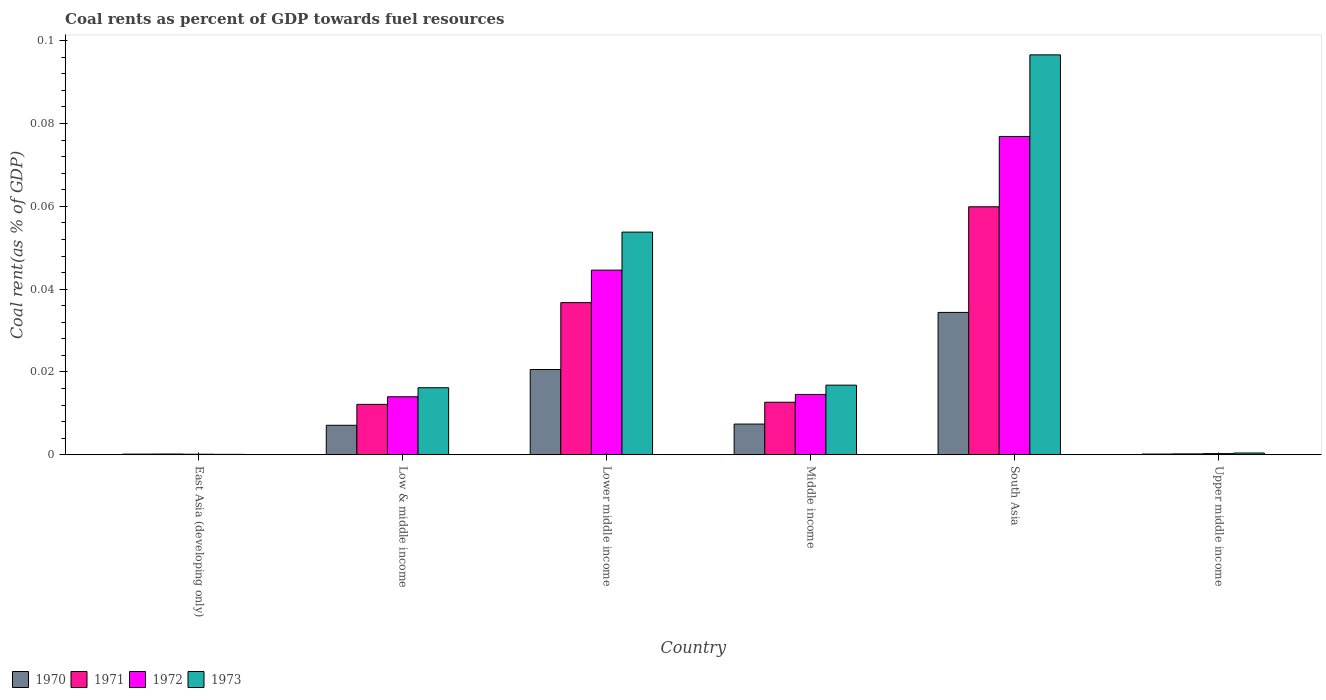How many different coloured bars are there?
Your answer should be compact. 4. How many groups of bars are there?
Ensure brevity in your answer.  6. Are the number of bars on each tick of the X-axis equal?
Make the answer very short. Yes. How many bars are there on the 3rd tick from the right?
Make the answer very short. 4. What is the label of the 3rd group of bars from the left?
Give a very brief answer. Lower middle income. In how many cases, is the number of bars for a given country not equal to the number of legend labels?
Offer a terse response. 0. What is the coal rent in 1972 in Middle income?
Your response must be concise. 0.01. Across all countries, what is the maximum coal rent in 1972?
Your answer should be compact. 0.08. Across all countries, what is the minimum coal rent in 1972?
Keep it short and to the point. 0. In which country was the coal rent in 1970 maximum?
Offer a very short reply. South Asia. In which country was the coal rent in 1972 minimum?
Make the answer very short. East Asia (developing only). What is the total coal rent in 1971 in the graph?
Offer a very short reply. 0.12. What is the difference between the coal rent in 1970 in East Asia (developing only) and that in Low & middle income?
Make the answer very short. -0.01. What is the difference between the coal rent in 1972 in Low & middle income and the coal rent in 1971 in South Asia?
Offer a terse response. -0.05. What is the average coal rent in 1971 per country?
Keep it short and to the point. 0.02. What is the difference between the coal rent of/in 1972 and coal rent of/in 1970 in Low & middle income?
Your response must be concise. 0.01. What is the ratio of the coal rent in 1973 in East Asia (developing only) to that in Low & middle income?
Keep it short and to the point. 0.01. What is the difference between the highest and the second highest coal rent in 1972?
Provide a short and direct response. 0.03. What is the difference between the highest and the lowest coal rent in 1971?
Your answer should be compact. 0.06. Is the sum of the coal rent in 1973 in South Asia and Upper middle income greater than the maximum coal rent in 1970 across all countries?
Ensure brevity in your answer.  Yes. What does the 3rd bar from the right in Middle income represents?
Ensure brevity in your answer.  1971. How many countries are there in the graph?
Your answer should be very brief. 6. What is the difference between two consecutive major ticks on the Y-axis?
Your response must be concise. 0.02. Does the graph contain any zero values?
Provide a succinct answer. No. How many legend labels are there?
Provide a succinct answer. 4. How are the legend labels stacked?
Provide a succinct answer. Horizontal. What is the title of the graph?
Ensure brevity in your answer.  Coal rents as percent of GDP towards fuel resources. Does "1996" appear as one of the legend labels in the graph?
Keep it short and to the point. No. What is the label or title of the Y-axis?
Your answer should be very brief. Coal rent(as % of GDP). What is the Coal rent(as % of GDP) of 1970 in East Asia (developing only)?
Give a very brief answer. 0. What is the Coal rent(as % of GDP) of 1971 in East Asia (developing only)?
Provide a succinct answer. 0. What is the Coal rent(as % of GDP) of 1972 in East Asia (developing only)?
Give a very brief answer. 0. What is the Coal rent(as % of GDP) of 1973 in East Asia (developing only)?
Offer a very short reply. 0. What is the Coal rent(as % of GDP) in 1970 in Low & middle income?
Your answer should be compact. 0.01. What is the Coal rent(as % of GDP) of 1971 in Low & middle income?
Provide a succinct answer. 0.01. What is the Coal rent(as % of GDP) of 1972 in Low & middle income?
Your answer should be compact. 0.01. What is the Coal rent(as % of GDP) in 1973 in Low & middle income?
Offer a terse response. 0.02. What is the Coal rent(as % of GDP) of 1970 in Lower middle income?
Offer a terse response. 0.02. What is the Coal rent(as % of GDP) in 1971 in Lower middle income?
Keep it short and to the point. 0.04. What is the Coal rent(as % of GDP) in 1972 in Lower middle income?
Your answer should be very brief. 0.04. What is the Coal rent(as % of GDP) in 1973 in Lower middle income?
Make the answer very short. 0.05. What is the Coal rent(as % of GDP) of 1970 in Middle income?
Your response must be concise. 0.01. What is the Coal rent(as % of GDP) in 1971 in Middle income?
Offer a very short reply. 0.01. What is the Coal rent(as % of GDP) of 1972 in Middle income?
Offer a terse response. 0.01. What is the Coal rent(as % of GDP) in 1973 in Middle income?
Offer a terse response. 0.02. What is the Coal rent(as % of GDP) in 1970 in South Asia?
Ensure brevity in your answer.  0.03. What is the Coal rent(as % of GDP) of 1971 in South Asia?
Keep it short and to the point. 0.06. What is the Coal rent(as % of GDP) of 1972 in South Asia?
Offer a terse response. 0.08. What is the Coal rent(as % of GDP) in 1973 in South Asia?
Offer a terse response. 0.1. What is the Coal rent(as % of GDP) of 1970 in Upper middle income?
Provide a short and direct response. 0. What is the Coal rent(as % of GDP) in 1971 in Upper middle income?
Your answer should be compact. 0. What is the Coal rent(as % of GDP) of 1972 in Upper middle income?
Provide a succinct answer. 0. What is the Coal rent(as % of GDP) in 1973 in Upper middle income?
Your answer should be very brief. 0. Across all countries, what is the maximum Coal rent(as % of GDP) of 1970?
Your response must be concise. 0.03. Across all countries, what is the maximum Coal rent(as % of GDP) in 1971?
Make the answer very short. 0.06. Across all countries, what is the maximum Coal rent(as % of GDP) in 1972?
Your response must be concise. 0.08. Across all countries, what is the maximum Coal rent(as % of GDP) in 1973?
Give a very brief answer. 0.1. Across all countries, what is the minimum Coal rent(as % of GDP) of 1970?
Ensure brevity in your answer.  0. Across all countries, what is the minimum Coal rent(as % of GDP) in 1971?
Provide a succinct answer. 0. Across all countries, what is the minimum Coal rent(as % of GDP) in 1972?
Keep it short and to the point. 0. Across all countries, what is the minimum Coal rent(as % of GDP) in 1973?
Ensure brevity in your answer.  0. What is the total Coal rent(as % of GDP) in 1970 in the graph?
Offer a terse response. 0.07. What is the total Coal rent(as % of GDP) of 1971 in the graph?
Your answer should be compact. 0.12. What is the total Coal rent(as % of GDP) in 1972 in the graph?
Offer a terse response. 0.15. What is the total Coal rent(as % of GDP) in 1973 in the graph?
Your answer should be compact. 0.18. What is the difference between the Coal rent(as % of GDP) in 1970 in East Asia (developing only) and that in Low & middle income?
Your answer should be compact. -0.01. What is the difference between the Coal rent(as % of GDP) of 1971 in East Asia (developing only) and that in Low & middle income?
Your answer should be very brief. -0.01. What is the difference between the Coal rent(as % of GDP) in 1972 in East Asia (developing only) and that in Low & middle income?
Provide a short and direct response. -0.01. What is the difference between the Coal rent(as % of GDP) in 1973 in East Asia (developing only) and that in Low & middle income?
Your answer should be very brief. -0.02. What is the difference between the Coal rent(as % of GDP) in 1970 in East Asia (developing only) and that in Lower middle income?
Give a very brief answer. -0.02. What is the difference between the Coal rent(as % of GDP) of 1971 in East Asia (developing only) and that in Lower middle income?
Offer a very short reply. -0.04. What is the difference between the Coal rent(as % of GDP) of 1972 in East Asia (developing only) and that in Lower middle income?
Keep it short and to the point. -0.04. What is the difference between the Coal rent(as % of GDP) in 1973 in East Asia (developing only) and that in Lower middle income?
Provide a succinct answer. -0.05. What is the difference between the Coal rent(as % of GDP) in 1970 in East Asia (developing only) and that in Middle income?
Your response must be concise. -0.01. What is the difference between the Coal rent(as % of GDP) in 1971 in East Asia (developing only) and that in Middle income?
Your response must be concise. -0.01. What is the difference between the Coal rent(as % of GDP) in 1972 in East Asia (developing only) and that in Middle income?
Your answer should be very brief. -0.01. What is the difference between the Coal rent(as % of GDP) of 1973 in East Asia (developing only) and that in Middle income?
Keep it short and to the point. -0.02. What is the difference between the Coal rent(as % of GDP) of 1970 in East Asia (developing only) and that in South Asia?
Give a very brief answer. -0.03. What is the difference between the Coal rent(as % of GDP) of 1971 in East Asia (developing only) and that in South Asia?
Offer a very short reply. -0.06. What is the difference between the Coal rent(as % of GDP) of 1972 in East Asia (developing only) and that in South Asia?
Your answer should be compact. -0.08. What is the difference between the Coal rent(as % of GDP) of 1973 in East Asia (developing only) and that in South Asia?
Provide a short and direct response. -0.1. What is the difference between the Coal rent(as % of GDP) of 1970 in East Asia (developing only) and that in Upper middle income?
Your response must be concise. -0. What is the difference between the Coal rent(as % of GDP) in 1972 in East Asia (developing only) and that in Upper middle income?
Provide a succinct answer. -0. What is the difference between the Coal rent(as % of GDP) in 1973 in East Asia (developing only) and that in Upper middle income?
Provide a succinct answer. -0. What is the difference between the Coal rent(as % of GDP) in 1970 in Low & middle income and that in Lower middle income?
Offer a very short reply. -0.01. What is the difference between the Coal rent(as % of GDP) in 1971 in Low & middle income and that in Lower middle income?
Make the answer very short. -0.02. What is the difference between the Coal rent(as % of GDP) of 1972 in Low & middle income and that in Lower middle income?
Offer a terse response. -0.03. What is the difference between the Coal rent(as % of GDP) of 1973 in Low & middle income and that in Lower middle income?
Give a very brief answer. -0.04. What is the difference between the Coal rent(as % of GDP) of 1970 in Low & middle income and that in Middle income?
Offer a terse response. -0. What is the difference between the Coal rent(as % of GDP) of 1971 in Low & middle income and that in Middle income?
Your response must be concise. -0. What is the difference between the Coal rent(as % of GDP) in 1972 in Low & middle income and that in Middle income?
Ensure brevity in your answer.  -0. What is the difference between the Coal rent(as % of GDP) in 1973 in Low & middle income and that in Middle income?
Give a very brief answer. -0. What is the difference between the Coal rent(as % of GDP) of 1970 in Low & middle income and that in South Asia?
Your response must be concise. -0.03. What is the difference between the Coal rent(as % of GDP) in 1971 in Low & middle income and that in South Asia?
Keep it short and to the point. -0.05. What is the difference between the Coal rent(as % of GDP) of 1972 in Low & middle income and that in South Asia?
Keep it short and to the point. -0.06. What is the difference between the Coal rent(as % of GDP) in 1973 in Low & middle income and that in South Asia?
Your answer should be compact. -0.08. What is the difference between the Coal rent(as % of GDP) of 1970 in Low & middle income and that in Upper middle income?
Provide a short and direct response. 0.01. What is the difference between the Coal rent(as % of GDP) of 1971 in Low & middle income and that in Upper middle income?
Offer a terse response. 0.01. What is the difference between the Coal rent(as % of GDP) of 1972 in Low & middle income and that in Upper middle income?
Your answer should be very brief. 0.01. What is the difference between the Coal rent(as % of GDP) of 1973 in Low & middle income and that in Upper middle income?
Make the answer very short. 0.02. What is the difference between the Coal rent(as % of GDP) in 1970 in Lower middle income and that in Middle income?
Your response must be concise. 0.01. What is the difference between the Coal rent(as % of GDP) of 1971 in Lower middle income and that in Middle income?
Your answer should be very brief. 0.02. What is the difference between the Coal rent(as % of GDP) of 1972 in Lower middle income and that in Middle income?
Your answer should be very brief. 0.03. What is the difference between the Coal rent(as % of GDP) of 1973 in Lower middle income and that in Middle income?
Your answer should be compact. 0.04. What is the difference between the Coal rent(as % of GDP) in 1970 in Lower middle income and that in South Asia?
Keep it short and to the point. -0.01. What is the difference between the Coal rent(as % of GDP) in 1971 in Lower middle income and that in South Asia?
Ensure brevity in your answer.  -0.02. What is the difference between the Coal rent(as % of GDP) of 1972 in Lower middle income and that in South Asia?
Offer a very short reply. -0.03. What is the difference between the Coal rent(as % of GDP) of 1973 in Lower middle income and that in South Asia?
Your response must be concise. -0.04. What is the difference between the Coal rent(as % of GDP) in 1970 in Lower middle income and that in Upper middle income?
Provide a succinct answer. 0.02. What is the difference between the Coal rent(as % of GDP) of 1971 in Lower middle income and that in Upper middle income?
Give a very brief answer. 0.04. What is the difference between the Coal rent(as % of GDP) of 1972 in Lower middle income and that in Upper middle income?
Offer a very short reply. 0.04. What is the difference between the Coal rent(as % of GDP) in 1973 in Lower middle income and that in Upper middle income?
Make the answer very short. 0.05. What is the difference between the Coal rent(as % of GDP) of 1970 in Middle income and that in South Asia?
Make the answer very short. -0.03. What is the difference between the Coal rent(as % of GDP) in 1971 in Middle income and that in South Asia?
Keep it short and to the point. -0.05. What is the difference between the Coal rent(as % of GDP) of 1972 in Middle income and that in South Asia?
Your answer should be compact. -0.06. What is the difference between the Coal rent(as % of GDP) of 1973 in Middle income and that in South Asia?
Keep it short and to the point. -0.08. What is the difference between the Coal rent(as % of GDP) in 1970 in Middle income and that in Upper middle income?
Your answer should be compact. 0.01. What is the difference between the Coal rent(as % of GDP) of 1971 in Middle income and that in Upper middle income?
Provide a short and direct response. 0.01. What is the difference between the Coal rent(as % of GDP) of 1972 in Middle income and that in Upper middle income?
Make the answer very short. 0.01. What is the difference between the Coal rent(as % of GDP) in 1973 in Middle income and that in Upper middle income?
Offer a very short reply. 0.02. What is the difference between the Coal rent(as % of GDP) in 1970 in South Asia and that in Upper middle income?
Make the answer very short. 0.03. What is the difference between the Coal rent(as % of GDP) in 1971 in South Asia and that in Upper middle income?
Give a very brief answer. 0.06. What is the difference between the Coal rent(as % of GDP) of 1972 in South Asia and that in Upper middle income?
Give a very brief answer. 0.08. What is the difference between the Coal rent(as % of GDP) in 1973 in South Asia and that in Upper middle income?
Ensure brevity in your answer.  0.1. What is the difference between the Coal rent(as % of GDP) in 1970 in East Asia (developing only) and the Coal rent(as % of GDP) in 1971 in Low & middle income?
Your answer should be very brief. -0.01. What is the difference between the Coal rent(as % of GDP) of 1970 in East Asia (developing only) and the Coal rent(as % of GDP) of 1972 in Low & middle income?
Your answer should be very brief. -0.01. What is the difference between the Coal rent(as % of GDP) in 1970 in East Asia (developing only) and the Coal rent(as % of GDP) in 1973 in Low & middle income?
Your response must be concise. -0.02. What is the difference between the Coal rent(as % of GDP) in 1971 in East Asia (developing only) and the Coal rent(as % of GDP) in 1972 in Low & middle income?
Provide a short and direct response. -0.01. What is the difference between the Coal rent(as % of GDP) of 1971 in East Asia (developing only) and the Coal rent(as % of GDP) of 1973 in Low & middle income?
Offer a terse response. -0.02. What is the difference between the Coal rent(as % of GDP) in 1972 in East Asia (developing only) and the Coal rent(as % of GDP) in 1973 in Low & middle income?
Your answer should be very brief. -0.02. What is the difference between the Coal rent(as % of GDP) in 1970 in East Asia (developing only) and the Coal rent(as % of GDP) in 1971 in Lower middle income?
Your response must be concise. -0.04. What is the difference between the Coal rent(as % of GDP) of 1970 in East Asia (developing only) and the Coal rent(as % of GDP) of 1972 in Lower middle income?
Give a very brief answer. -0.04. What is the difference between the Coal rent(as % of GDP) in 1970 in East Asia (developing only) and the Coal rent(as % of GDP) in 1973 in Lower middle income?
Provide a short and direct response. -0.05. What is the difference between the Coal rent(as % of GDP) of 1971 in East Asia (developing only) and the Coal rent(as % of GDP) of 1972 in Lower middle income?
Keep it short and to the point. -0.04. What is the difference between the Coal rent(as % of GDP) in 1971 in East Asia (developing only) and the Coal rent(as % of GDP) in 1973 in Lower middle income?
Keep it short and to the point. -0.05. What is the difference between the Coal rent(as % of GDP) in 1972 in East Asia (developing only) and the Coal rent(as % of GDP) in 1973 in Lower middle income?
Provide a succinct answer. -0.05. What is the difference between the Coal rent(as % of GDP) in 1970 in East Asia (developing only) and the Coal rent(as % of GDP) in 1971 in Middle income?
Provide a succinct answer. -0.01. What is the difference between the Coal rent(as % of GDP) in 1970 in East Asia (developing only) and the Coal rent(as % of GDP) in 1972 in Middle income?
Make the answer very short. -0.01. What is the difference between the Coal rent(as % of GDP) in 1970 in East Asia (developing only) and the Coal rent(as % of GDP) in 1973 in Middle income?
Your answer should be very brief. -0.02. What is the difference between the Coal rent(as % of GDP) of 1971 in East Asia (developing only) and the Coal rent(as % of GDP) of 1972 in Middle income?
Keep it short and to the point. -0.01. What is the difference between the Coal rent(as % of GDP) in 1971 in East Asia (developing only) and the Coal rent(as % of GDP) in 1973 in Middle income?
Your response must be concise. -0.02. What is the difference between the Coal rent(as % of GDP) in 1972 in East Asia (developing only) and the Coal rent(as % of GDP) in 1973 in Middle income?
Offer a terse response. -0.02. What is the difference between the Coal rent(as % of GDP) of 1970 in East Asia (developing only) and the Coal rent(as % of GDP) of 1971 in South Asia?
Make the answer very short. -0.06. What is the difference between the Coal rent(as % of GDP) of 1970 in East Asia (developing only) and the Coal rent(as % of GDP) of 1972 in South Asia?
Offer a very short reply. -0.08. What is the difference between the Coal rent(as % of GDP) of 1970 in East Asia (developing only) and the Coal rent(as % of GDP) of 1973 in South Asia?
Give a very brief answer. -0.1. What is the difference between the Coal rent(as % of GDP) of 1971 in East Asia (developing only) and the Coal rent(as % of GDP) of 1972 in South Asia?
Offer a terse response. -0.08. What is the difference between the Coal rent(as % of GDP) in 1971 in East Asia (developing only) and the Coal rent(as % of GDP) in 1973 in South Asia?
Your answer should be very brief. -0.1. What is the difference between the Coal rent(as % of GDP) in 1972 in East Asia (developing only) and the Coal rent(as % of GDP) in 1973 in South Asia?
Your response must be concise. -0.1. What is the difference between the Coal rent(as % of GDP) of 1970 in East Asia (developing only) and the Coal rent(as % of GDP) of 1971 in Upper middle income?
Provide a short and direct response. -0. What is the difference between the Coal rent(as % of GDP) in 1970 in East Asia (developing only) and the Coal rent(as % of GDP) in 1972 in Upper middle income?
Give a very brief answer. -0. What is the difference between the Coal rent(as % of GDP) in 1970 in East Asia (developing only) and the Coal rent(as % of GDP) in 1973 in Upper middle income?
Your answer should be very brief. -0. What is the difference between the Coal rent(as % of GDP) of 1971 in East Asia (developing only) and the Coal rent(as % of GDP) of 1972 in Upper middle income?
Provide a succinct answer. -0. What is the difference between the Coal rent(as % of GDP) of 1971 in East Asia (developing only) and the Coal rent(as % of GDP) of 1973 in Upper middle income?
Your response must be concise. -0. What is the difference between the Coal rent(as % of GDP) of 1972 in East Asia (developing only) and the Coal rent(as % of GDP) of 1973 in Upper middle income?
Make the answer very short. -0. What is the difference between the Coal rent(as % of GDP) of 1970 in Low & middle income and the Coal rent(as % of GDP) of 1971 in Lower middle income?
Provide a succinct answer. -0.03. What is the difference between the Coal rent(as % of GDP) in 1970 in Low & middle income and the Coal rent(as % of GDP) in 1972 in Lower middle income?
Provide a short and direct response. -0.04. What is the difference between the Coal rent(as % of GDP) in 1970 in Low & middle income and the Coal rent(as % of GDP) in 1973 in Lower middle income?
Make the answer very short. -0.05. What is the difference between the Coal rent(as % of GDP) of 1971 in Low & middle income and the Coal rent(as % of GDP) of 1972 in Lower middle income?
Your answer should be compact. -0.03. What is the difference between the Coal rent(as % of GDP) of 1971 in Low & middle income and the Coal rent(as % of GDP) of 1973 in Lower middle income?
Offer a terse response. -0.04. What is the difference between the Coal rent(as % of GDP) of 1972 in Low & middle income and the Coal rent(as % of GDP) of 1973 in Lower middle income?
Offer a terse response. -0.04. What is the difference between the Coal rent(as % of GDP) in 1970 in Low & middle income and the Coal rent(as % of GDP) in 1971 in Middle income?
Make the answer very short. -0.01. What is the difference between the Coal rent(as % of GDP) of 1970 in Low & middle income and the Coal rent(as % of GDP) of 1972 in Middle income?
Your answer should be compact. -0.01. What is the difference between the Coal rent(as % of GDP) of 1970 in Low & middle income and the Coal rent(as % of GDP) of 1973 in Middle income?
Give a very brief answer. -0.01. What is the difference between the Coal rent(as % of GDP) in 1971 in Low & middle income and the Coal rent(as % of GDP) in 1972 in Middle income?
Make the answer very short. -0. What is the difference between the Coal rent(as % of GDP) of 1971 in Low & middle income and the Coal rent(as % of GDP) of 1973 in Middle income?
Provide a succinct answer. -0. What is the difference between the Coal rent(as % of GDP) of 1972 in Low & middle income and the Coal rent(as % of GDP) of 1973 in Middle income?
Provide a succinct answer. -0. What is the difference between the Coal rent(as % of GDP) in 1970 in Low & middle income and the Coal rent(as % of GDP) in 1971 in South Asia?
Your response must be concise. -0.05. What is the difference between the Coal rent(as % of GDP) in 1970 in Low & middle income and the Coal rent(as % of GDP) in 1972 in South Asia?
Your answer should be very brief. -0.07. What is the difference between the Coal rent(as % of GDP) of 1970 in Low & middle income and the Coal rent(as % of GDP) of 1973 in South Asia?
Offer a very short reply. -0.09. What is the difference between the Coal rent(as % of GDP) in 1971 in Low & middle income and the Coal rent(as % of GDP) in 1972 in South Asia?
Offer a terse response. -0.06. What is the difference between the Coal rent(as % of GDP) in 1971 in Low & middle income and the Coal rent(as % of GDP) in 1973 in South Asia?
Offer a terse response. -0.08. What is the difference between the Coal rent(as % of GDP) of 1972 in Low & middle income and the Coal rent(as % of GDP) of 1973 in South Asia?
Give a very brief answer. -0.08. What is the difference between the Coal rent(as % of GDP) in 1970 in Low & middle income and the Coal rent(as % of GDP) in 1971 in Upper middle income?
Make the answer very short. 0.01. What is the difference between the Coal rent(as % of GDP) in 1970 in Low & middle income and the Coal rent(as % of GDP) in 1972 in Upper middle income?
Your response must be concise. 0.01. What is the difference between the Coal rent(as % of GDP) of 1970 in Low & middle income and the Coal rent(as % of GDP) of 1973 in Upper middle income?
Your answer should be compact. 0.01. What is the difference between the Coal rent(as % of GDP) of 1971 in Low & middle income and the Coal rent(as % of GDP) of 1972 in Upper middle income?
Offer a terse response. 0.01. What is the difference between the Coal rent(as % of GDP) in 1971 in Low & middle income and the Coal rent(as % of GDP) in 1973 in Upper middle income?
Your answer should be compact. 0.01. What is the difference between the Coal rent(as % of GDP) of 1972 in Low & middle income and the Coal rent(as % of GDP) of 1973 in Upper middle income?
Your answer should be compact. 0.01. What is the difference between the Coal rent(as % of GDP) of 1970 in Lower middle income and the Coal rent(as % of GDP) of 1971 in Middle income?
Ensure brevity in your answer.  0.01. What is the difference between the Coal rent(as % of GDP) of 1970 in Lower middle income and the Coal rent(as % of GDP) of 1972 in Middle income?
Keep it short and to the point. 0.01. What is the difference between the Coal rent(as % of GDP) of 1970 in Lower middle income and the Coal rent(as % of GDP) of 1973 in Middle income?
Keep it short and to the point. 0. What is the difference between the Coal rent(as % of GDP) in 1971 in Lower middle income and the Coal rent(as % of GDP) in 1972 in Middle income?
Ensure brevity in your answer.  0.02. What is the difference between the Coal rent(as % of GDP) of 1971 in Lower middle income and the Coal rent(as % of GDP) of 1973 in Middle income?
Ensure brevity in your answer.  0.02. What is the difference between the Coal rent(as % of GDP) of 1972 in Lower middle income and the Coal rent(as % of GDP) of 1973 in Middle income?
Your response must be concise. 0.03. What is the difference between the Coal rent(as % of GDP) of 1970 in Lower middle income and the Coal rent(as % of GDP) of 1971 in South Asia?
Provide a succinct answer. -0.04. What is the difference between the Coal rent(as % of GDP) of 1970 in Lower middle income and the Coal rent(as % of GDP) of 1972 in South Asia?
Make the answer very short. -0.06. What is the difference between the Coal rent(as % of GDP) of 1970 in Lower middle income and the Coal rent(as % of GDP) of 1973 in South Asia?
Offer a terse response. -0.08. What is the difference between the Coal rent(as % of GDP) of 1971 in Lower middle income and the Coal rent(as % of GDP) of 1972 in South Asia?
Ensure brevity in your answer.  -0.04. What is the difference between the Coal rent(as % of GDP) in 1971 in Lower middle income and the Coal rent(as % of GDP) in 1973 in South Asia?
Your response must be concise. -0.06. What is the difference between the Coal rent(as % of GDP) in 1972 in Lower middle income and the Coal rent(as % of GDP) in 1973 in South Asia?
Provide a succinct answer. -0.05. What is the difference between the Coal rent(as % of GDP) in 1970 in Lower middle income and the Coal rent(as % of GDP) in 1971 in Upper middle income?
Make the answer very short. 0.02. What is the difference between the Coal rent(as % of GDP) in 1970 in Lower middle income and the Coal rent(as % of GDP) in 1972 in Upper middle income?
Give a very brief answer. 0.02. What is the difference between the Coal rent(as % of GDP) in 1970 in Lower middle income and the Coal rent(as % of GDP) in 1973 in Upper middle income?
Ensure brevity in your answer.  0.02. What is the difference between the Coal rent(as % of GDP) in 1971 in Lower middle income and the Coal rent(as % of GDP) in 1972 in Upper middle income?
Provide a succinct answer. 0.04. What is the difference between the Coal rent(as % of GDP) of 1971 in Lower middle income and the Coal rent(as % of GDP) of 1973 in Upper middle income?
Your answer should be compact. 0.04. What is the difference between the Coal rent(as % of GDP) in 1972 in Lower middle income and the Coal rent(as % of GDP) in 1973 in Upper middle income?
Ensure brevity in your answer.  0.04. What is the difference between the Coal rent(as % of GDP) in 1970 in Middle income and the Coal rent(as % of GDP) in 1971 in South Asia?
Offer a very short reply. -0.05. What is the difference between the Coal rent(as % of GDP) in 1970 in Middle income and the Coal rent(as % of GDP) in 1972 in South Asia?
Provide a succinct answer. -0.07. What is the difference between the Coal rent(as % of GDP) of 1970 in Middle income and the Coal rent(as % of GDP) of 1973 in South Asia?
Your answer should be very brief. -0.09. What is the difference between the Coal rent(as % of GDP) in 1971 in Middle income and the Coal rent(as % of GDP) in 1972 in South Asia?
Keep it short and to the point. -0.06. What is the difference between the Coal rent(as % of GDP) of 1971 in Middle income and the Coal rent(as % of GDP) of 1973 in South Asia?
Your answer should be compact. -0.08. What is the difference between the Coal rent(as % of GDP) in 1972 in Middle income and the Coal rent(as % of GDP) in 1973 in South Asia?
Your response must be concise. -0.08. What is the difference between the Coal rent(as % of GDP) in 1970 in Middle income and the Coal rent(as % of GDP) in 1971 in Upper middle income?
Give a very brief answer. 0.01. What is the difference between the Coal rent(as % of GDP) of 1970 in Middle income and the Coal rent(as % of GDP) of 1972 in Upper middle income?
Give a very brief answer. 0.01. What is the difference between the Coal rent(as % of GDP) of 1970 in Middle income and the Coal rent(as % of GDP) of 1973 in Upper middle income?
Your answer should be compact. 0.01. What is the difference between the Coal rent(as % of GDP) in 1971 in Middle income and the Coal rent(as % of GDP) in 1972 in Upper middle income?
Give a very brief answer. 0.01. What is the difference between the Coal rent(as % of GDP) in 1971 in Middle income and the Coal rent(as % of GDP) in 1973 in Upper middle income?
Provide a short and direct response. 0.01. What is the difference between the Coal rent(as % of GDP) in 1972 in Middle income and the Coal rent(as % of GDP) in 1973 in Upper middle income?
Your answer should be very brief. 0.01. What is the difference between the Coal rent(as % of GDP) of 1970 in South Asia and the Coal rent(as % of GDP) of 1971 in Upper middle income?
Provide a succinct answer. 0.03. What is the difference between the Coal rent(as % of GDP) of 1970 in South Asia and the Coal rent(as % of GDP) of 1972 in Upper middle income?
Provide a succinct answer. 0.03. What is the difference between the Coal rent(as % of GDP) of 1970 in South Asia and the Coal rent(as % of GDP) of 1973 in Upper middle income?
Offer a very short reply. 0.03. What is the difference between the Coal rent(as % of GDP) of 1971 in South Asia and the Coal rent(as % of GDP) of 1972 in Upper middle income?
Keep it short and to the point. 0.06. What is the difference between the Coal rent(as % of GDP) of 1971 in South Asia and the Coal rent(as % of GDP) of 1973 in Upper middle income?
Your answer should be compact. 0.06. What is the difference between the Coal rent(as % of GDP) in 1972 in South Asia and the Coal rent(as % of GDP) in 1973 in Upper middle income?
Offer a terse response. 0.08. What is the average Coal rent(as % of GDP) of 1970 per country?
Ensure brevity in your answer.  0.01. What is the average Coal rent(as % of GDP) in 1971 per country?
Offer a very short reply. 0.02. What is the average Coal rent(as % of GDP) of 1972 per country?
Keep it short and to the point. 0.03. What is the average Coal rent(as % of GDP) in 1973 per country?
Give a very brief answer. 0.03. What is the difference between the Coal rent(as % of GDP) of 1970 and Coal rent(as % of GDP) of 1971 in East Asia (developing only)?
Ensure brevity in your answer.  -0. What is the difference between the Coal rent(as % of GDP) in 1970 and Coal rent(as % of GDP) in 1972 in East Asia (developing only)?
Your answer should be compact. 0. What is the difference between the Coal rent(as % of GDP) of 1971 and Coal rent(as % of GDP) of 1972 in East Asia (developing only)?
Keep it short and to the point. 0. What is the difference between the Coal rent(as % of GDP) of 1972 and Coal rent(as % of GDP) of 1973 in East Asia (developing only)?
Offer a terse response. 0. What is the difference between the Coal rent(as % of GDP) in 1970 and Coal rent(as % of GDP) in 1971 in Low & middle income?
Give a very brief answer. -0.01. What is the difference between the Coal rent(as % of GDP) of 1970 and Coal rent(as % of GDP) of 1972 in Low & middle income?
Your answer should be very brief. -0.01. What is the difference between the Coal rent(as % of GDP) in 1970 and Coal rent(as % of GDP) in 1973 in Low & middle income?
Your answer should be compact. -0.01. What is the difference between the Coal rent(as % of GDP) in 1971 and Coal rent(as % of GDP) in 1972 in Low & middle income?
Provide a short and direct response. -0. What is the difference between the Coal rent(as % of GDP) in 1971 and Coal rent(as % of GDP) in 1973 in Low & middle income?
Your answer should be compact. -0. What is the difference between the Coal rent(as % of GDP) of 1972 and Coal rent(as % of GDP) of 1973 in Low & middle income?
Ensure brevity in your answer.  -0. What is the difference between the Coal rent(as % of GDP) in 1970 and Coal rent(as % of GDP) in 1971 in Lower middle income?
Give a very brief answer. -0.02. What is the difference between the Coal rent(as % of GDP) in 1970 and Coal rent(as % of GDP) in 1972 in Lower middle income?
Your response must be concise. -0.02. What is the difference between the Coal rent(as % of GDP) of 1970 and Coal rent(as % of GDP) of 1973 in Lower middle income?
Make the answer very short. -0.03. What is the difference between the Coal rent(as % of GDP) in 1971 and Coal rent(as % of GDP) in 1972 in Lower middle income?
Give a very brief answer. -0.01. What is the difference between the Coal rent(as % of GDP) in 1971 and Coal rent(as % of GDP) in 1973 in Lower middle income?
Keep it short and to the point. -0.02. What is the difference between the Coal rent(as % of GDP) of 1972 and Coal rent(as % of GDP) of 1973 in Lower middle income?
Make the answer very short. -0.01. What is the difference between the Coal rent(as % of GDP) in 1970 and Coal rent(as % of GDP) in 1971 in Middle income?
Keep it short and to the point. -0.01. What is the difference between the Coal rent(as % of GDP) of 1970 and Coal rent(as % of GDP) of 1972 in Middle income?
Provide a succinct answer. -0.01. What is the difference between the Coal rent(as % of GDP) in 1970 and Coal rent(as % of GDP) in 1973 in Middle income?
Your response must be concise. -0.01. What is the difference between the Coal rent(as % of GDP) of 1971 and Coal rent(as % of GDP) of 1972 in Middle income?
Your answer should be very brief. -0. What is the difference between the Coal rent(as % of GDP) in 1971 and Coal rent(as % of GDP) in 1973 in Middle income?
Your answer should be very brief. -0. What is the difference between the Coal rent(as % of GDP) of 1972 and Coal rent(as % of GDP) of 1973 in Middle income?
Your response must be concise. -0. What is the difference between the Coal rent(as % of GDP) of 1970 and Coal rent(as % of GDP) of 1971 in South Asia?
Provide a succinct answer. -0.03. What is the difference between the Coal rent(as % of GDP) of 1970 and Coal rent(as % of GDP) of 1972 in South Asia?
Your response must be concise. -0.04. What is the difference between the Coal rent(as % of GDP) of 1970 and Coal rent(as % of GDP) of 1973 in South Asia?
Your response must be concise. -0.06. What is the difference between the Coal rent(as % of GDP) in 1971 and Coal rent(as % of GDP) in 1972 in South Asia?
Your answer should be very brief. -0.02. What is the difference between the Coal rent(as % of GDP) in 1971 and Coal rent(as % of GDP) in 1973 in South Asia?
Give a very brief answer. -0.04. What is the difference between the Coal rent(as % of GDP) of 1972 and Coal rent(as % of GDP) of 1973 in South Asia?
Provide a succinct answer. -0.02. What is the difference between the Coal rent(as % of GDP) in 1970 and Coal rent(as % of GDP) in 1971 in Upper middle income?
Your answer should be very brief. -0. What is the difference between the Coal rent(as % of GDP) in 1970 and Coal rent(as % of GDP) in 1972 in Upper middle income?
Ensure brevity in your answer.  -0. What is the difference between the Coal rent(as % of GDP) of 1970 and Coal rent(as % of GDP) of 1973 in Upper middle income?
Offer a terse response. -0. What is the difference between the Coal rent(as % of GDP) of 1971 and Coal rent(as % of GDP) of 1972 in Upper middle income?
Ensure brevity in your answer.  -0. What is the difference between the Coal rent(as % of GDP) of 1971 and Coal rent(as % of GDP) of 1973 in Upper middle income?
Your answer should be very brief. -0. What is the difference between the Coal rent(as % of GDP) of 1972 and Coal rent(as % of GDP) of 1973 in Upper middle income?
Provide a succinct answer. -0. What is the ratio of the Coal rent(as % of GDP) in 1970 in East Asia (developing only) to that in Low & middle income?
Ensure brevity in your answer.  0.02. What is the ratio of the Coal rent(as % of GDP) in 1971 in East Asia (developing only) to that in Low & middle income?
Your answer should be very brief. 0.02. What is the ratio of the Coal rent(as % of GDP) in 1972 in East Asia (developing only) to that in Low & middle income?
Your answer should be very brief. 0.01. What is the ratio of the Coal rent(as % of GDP) in 1973 in East Asia (developing only) to that in Low & middle income?
Your response must be concise. 0.01. What is the ratio of the Coal rent(as % of GDP) in 1970 in East Asia (developing only) to that in Lower middle income?
Your answer should be compact. 0.01. What is the ratio of the Coal rent(as % of GDP) in 1971 in East Asia (developing only) to that in Lower middle income?
Offer a very short reply. 0.01. What is the ratio of the Coal rent(as % of GDP) in 1972 in East Asia (developing only) to that in Lower middle income?
Offer a very short reply. 0. What is the ratio of the Coal rent(as % of GDP) of 1973 in East Asia (developing only) to that in Lower middle income?
Your answer should be very brief. 0. What is the ratio of the Coal rent(as % of GDP) in 1970 in East Asia (developing only) to that in Middle income?
Provide a succinct answer. 0.02. What is the ratio of the Coal rent(as % of GDP) in 1971 in East Asia (developing only) to that in Middle income?
Provide a succinct answer. 0.01. What is the ratio of the Coal rent(as % of GDP) in 1972 in East Asia (developing only) to that in Middle income?
Provide a short and direct response. 0.01. What is the ratio of the Coal rent(as % of GDP) of 1973 in East Asia (developing only) to that in Middle income?
Keep it short and to the point. 0.01. What is the ratio of the Coal rent(as % of GDP) in 1970 in East Asia (developing only) to that in South Asia?
Ensure brevity in your answer.  0. What is the ratio of the Coal rent(as % of GDP) of 1971 in East Asia (developing only) to that in South Asia?
Provide a short and direct response. 0. What is the ratio of the Coal rent(as % of GDP) of 1972 in East Asia (developing only) to that in South Asia?
Offer a very short reply. 0. What is the ratio of the Coal rent(as % of GDP) in 1973 in East Asia (developing only) to that in South Asia?
Offer a terse response. 0. What is the ratio of the Coal rent(as % of GDP) in 1970 in East Asia (developing only) to that in Upper middle income?
Give a very brief answer. 0.91. What is the ratio of the Coal rent(as % of GDP) in 1971 in East Asia (developing only) to that in Upper middle income?
Provide a succinct answer. 0.86. What is the ratio of the Coal rent(as % of GDP) in 1972 in East Asia (developing only) to that in Upper middle income?
Offer a very short reply. 0.48. What is the ratio of the Coal rent(as % of GDP) of 1973 in East Asia (developing only) to that in Upper middle income?
Ensure brevity in your answer.  0.24. What is the ratio of the Coal rent(as % of GDP) of 1970 in Low & middle income to that in Lower middle income?
Keep it short and to the point. 0.35. What is the ratio of the Coal rent(as % of GDP) in 1971 in Low & middle income to that in Lower middle income?
Keep it short and to the point. 0.33. What is the ratio of the Coal rent(as % of GDP) of 1972 in Low & middle income to that in Lower middle income?
Provide a succinct answer. 0.31. What is the ratio of the Coal rent(as % of GDP) of 1973 in Low & middle income to that in Lower middle income?
Provide a short and direct response. 0.3. What is the ratio of the Coal rent(as % of GDP) of 1970 in Low & middle income to that in Middle income?
Offer a very short reply. 0.96. What is the ratio of the Coal rent(as % of GDP) of 1971 in Low & middle income to that in Middle income?
Provide a succinct answer. 0.96. What is the ratio of the Coal rent(as % of GDP) of 1972 in Low & middle income to that in Middle income?
Keep it short and to the point. 0.96. What is the ratio of the Coal rent(as % of GDP) in 1973 in Low & middle income to that in Middle income?
Offer a terse response. 0.96. What is the ratio of the Coal rent(as % of GDP) of 1970 in Low & middle income to that in South Asia?
Provide a short and direct response. 0.21. What is the ratio of the Coal rent(as % of GDP) of 1971 in Low & middle income to that in South Asia?
Provide a short and direct response. 0.2. What is the ratio of the Coal rent(as % of GDP) in 1972 in Low & middle income to that in South Asia?
Give a very brief answer. 0.18. What is the ratio of the Coal rent(as % of GDP) of 1973 in Low & middle income to that in South Asia?
Ensure brevity in your answer.  0.17. What is the ratio of the Coal rent(as % of GDP) of 1970 in Low & middle income to that in Upper middle income?
Provide a succinct answer. 38.77. What is the ratio of the Coal rent(as % of GDP) of 1971 in Low & middle income to that in Upper middle income?
Your answer should be compact. 55.66. What is the ratio of the Coal rent(as % of GDP) in 1972 in Low & middle income to that in Upper middle income?
Give a very brief answer. 49.28. What is the ratio of the Coal rent(as % of GDP) in 1973 in Low & middle income to that in Upper middle income?
Offer a terse response. 37.59. What is the ratio of the Coal rent(as % of GDP) of 1970 in Lower middle income to that in Middle income?
Make the answer very short. 2.78. What is the ratio of the Coal rent(as % of GDP) in 1971 in Lower middle income to that in Middle income?
Offer a very short reply. 2.9. What is the ratio of the Coal rent(as % of GDP) of 1972 in Lower middle income to that in Middle income?
Offer a very short reply. 3.06. What is the ratio of the Coal rent(as % of GDP) in 1973 in Lower middle income to that in Middle income?
Provide a succinct answer. 3.2. What is the ratio of the Coal rent(as % of GDP) in 1970 in Lower middle income to that in South Asia?
Keep it short and to the point. 0.6. What is the ratio of the Coal rent(as % of GDP) of 1971 in Lower middle income to that in South Asia?
Keep it short and to the point. 0.61. What is the ratio of the Coal rent(as % of GDP) in 1972 in Lower middle income to that in South Asia?
Ensure brevity in your answer.  0.58. What is the ratio of the Coal rent(as % of GDP) of 1973 in Lower middle income to that in South Asia?
Ensure brevity in your answer.  0.56. What is the ratio of the Coal rent(as % of GDP) in 1970 in Lower middle income to that in Upper middle income?
Make the answer very short. 112.03. What is the ratio of the Coal rent(as % of GDP) of 1971 in Lower middle income to that in Upper middle income?
Offer a very short reply. 167.98. What is the ratio of the Coal rent(as % of GDP) of 1972 in Lower middle income to that in Upper middle income?
Provide a succinct answer. 156.82. What is the ratio of the Coal rent(as % of GDP) of 1973 in Lower middle income to that in Upper middle income?
Provide a succinct answer. 124.82. What is the ratio of the Coal rent(as % of GDP) in 1970 in Middle income to that in South Asia?
Give a very brief answer. 0.22. What is the ratio of the Coal rent(as % of GDP) of 1971 in Middle income to that in South Asia?
Offer a very short reply. 0.21. What is the ratio of the Coal rent(as % of GDP) of 1972 in Middle income to that in South Asia?
Ensure brevity in your answer.  0.19. What is the ratio of the Coal rent(as % of GDP) in 1973 in Middle income to that in South Asia?
Your answer should be very brief. 0.17. What is the ratio of the Coal rent(as % of GDP) of 1970 in Middle income to that in Upper middle income?
Keep it short and to the point. 40.36. What is the ratio of the Coal rent(as % of GDP) of 1971 in Middle income to that in Upper middle income?
Give a very brief answer. 58.01. What is the ratio of the Coal rent(as % of GDP) of 1972 in Middle income to that in Upper middle income?
Provide a succinct answer. 51.25. What is the ratio of the Coal rent(as % of GDP) of 1973 in Middle income to that in Upper middle income?
Offer a very short reply. 39.04. What is the ratio of the Coal rent(as % of GDP) in 1970 in South Asia to that in Upper middle income?
Keep it short and to the point. 187.05. What is the ratio of the Coal rent(as % of GDP) of 1971 in South Asia to that in Upper middle income?
Provide a short and direct response. 273.74. What is the ratio of the Coal rent(as % of GDP) in 1972 in South Asia to that in Upper middle income?
Make the answer very short. 270.32. What is the ratio of the Coal rent(as % of GDP) of 1973 in South Asia to that in Upper middle income?
Make the answer very short. 224.18. What is the difference between the highest and the second highest Coal rent(as % of GDP) of 1970?
Offer a terse response. 0.01. What is the difference between the highest and the second highest Coal rent(as % of GDP) of 1971?
Provide a short and direct response. 0.02. What is the difference between the highest and the second highest Coal rent(as % of GDP) in 1972?
Provide a succinct answer. 0.03. What is the difference between the highest and the second highest Coal rent(as % of GDP) in 1973?
Give a very brief answer. 0.04. What is the difference between the highest and the lowest Coal rent(as % of GDP) in 1970?
Your answer should be very brief. 0.03. What is the difference between the highest and the lowest Coal rent(as % of GDP) of 1971?
Provide a short and direct response. 0.06. What is the difference between the highest and the lowest Coal rent(as % of GDP) of 1972?
Your answer should be compact. 0.08. What is the difference between the highest and the lowest Coal rent(as % of GDP) of 1973?
Provide a short and direct response. 0.1. 